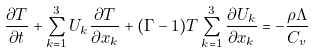Convert formula to latex. <formula><loc_0><loc_0><loc_500><loc_500>\frac { \partial T } { \partial t } + \sum _ { k = 1 } ^ { 3 } U _ { k } \frac { \partial T } { \partial x _ { k } } + ( \Gamma - 1 ) T \sum _ { k = 1 } ^ { 3 } \frac { \partial U _ { k } } { \partial x _ { k } } = - \frac { \rho \Lambda } { C _ { v } }</formula> 